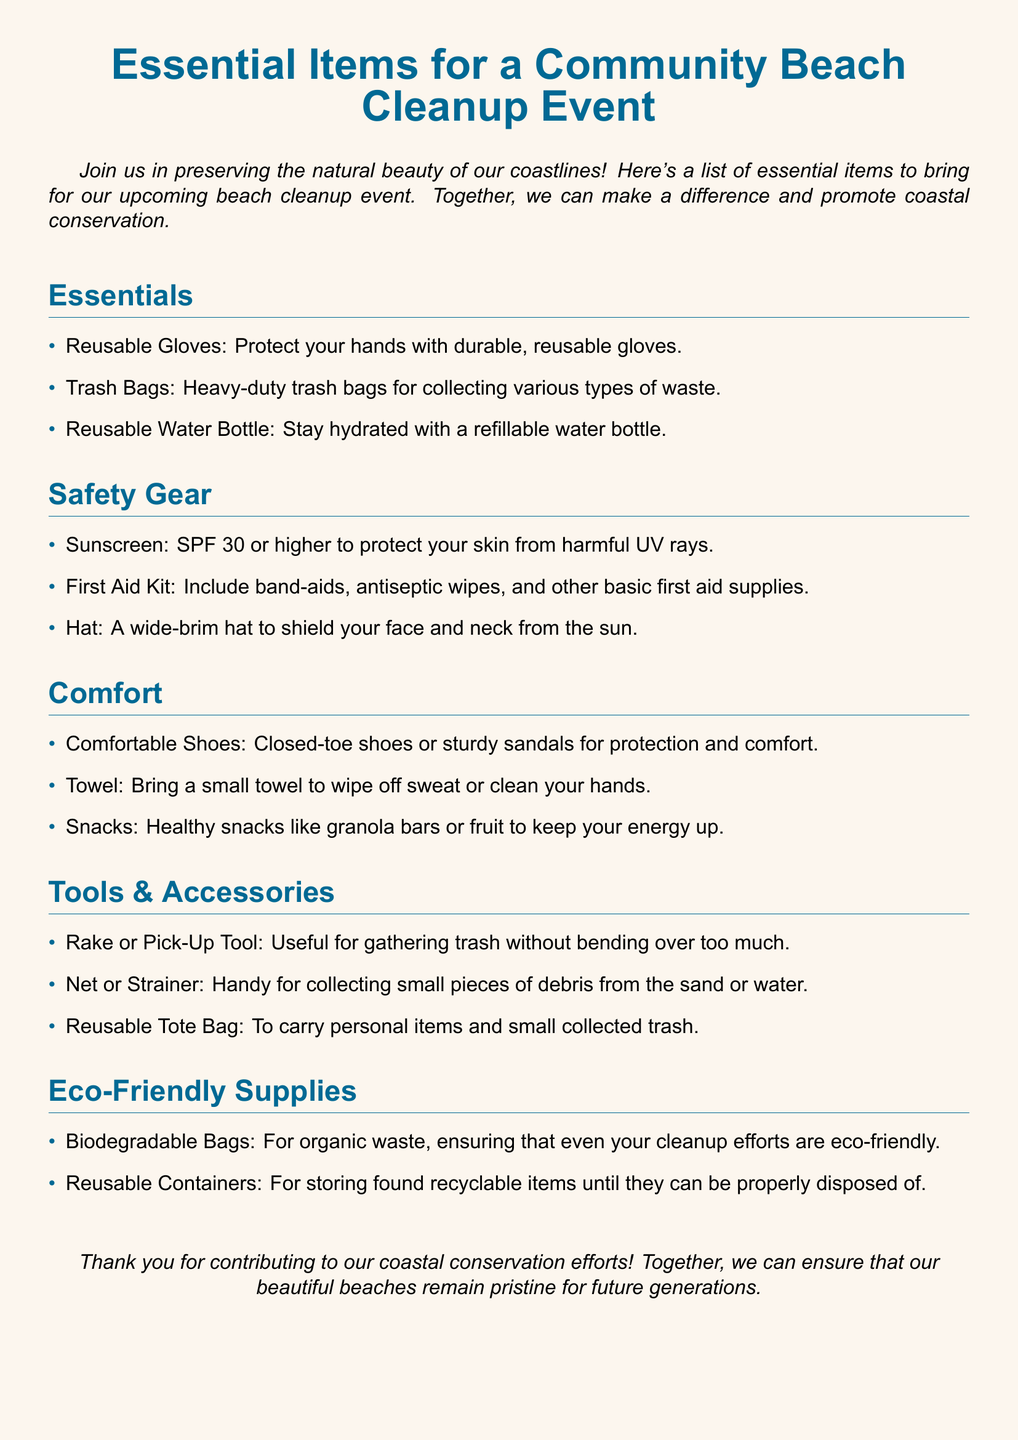What is the purpose of the beach cleanup event? The document states that the purpose is to preserve the natural beauty of coastlines and promote coastal conservation.
Answer: Preserve natural beauty How many sections are there in the packing list? The document contains five sections including Essentials, Safety Gear, Comfort, Tools & Accessories, and Eco-Friendly Supplies.
Answer: Five What item is recommended for hand protection? The document suggests bringing reusable gloves to protect your hands.
Answer: Reusable Gloves What should participants bring to stay hydrated? The document advises bringing a reusable water bottle for hydration.
Answer: Reusable Water Bottle Which sunscreen SPF is recommended? According to the document, an SPF of 30 or higher is recommended for sunscreen.
Answer: SPF 30 What type of footwear is suggested for comfort? The document recommends wearing closed-toe shoes or sturdy sandals for comfort and protection.
Answer: Comfortable Shoes Which item is mentioned for collecting small debris? A net or strainer is mentioned in the document for collecting small pieces of debris.
Answer: Net or Strainer What should be included in the first aid kit? The document suggests including band-aids and antiseptic wipes among other basic first aid supplies.
Answer: Band-aids What eco-friendly bags are recommended for organic waste? Biodegradable bags are specified in the document for organic waste collection.
Answer: Biodegradable Bags 